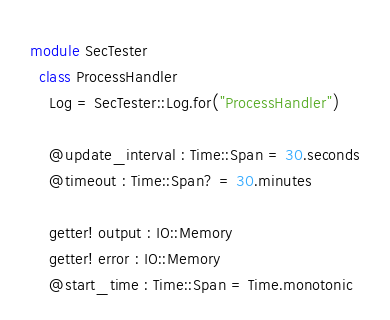Convert code to text. <code><loc_0><loc_0><loc_500><loc_500><_Crystal_>module SecTester
  class ProcessHandler
    Log = SecTester::Log.for("ProcessHandler")

    @update_interval : Time::Span = 30.seconds
    @timeout : Time::Span? = 30.minutes

    getter! output : IO::Memory
    getter! error : IO::Memory
    @start_time : Time::Span = Time.monotonic
</code> 